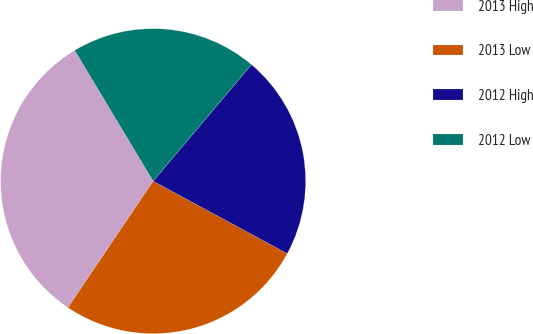Convert chart to OTSL. <chart><loc_0><loc_0><loc_500><loc_500><pie_chart><fcel>2013 High<fcel>2013 Low<fcel>2012 High<fcel>2012 Low<nl><fcel>31.97%<fcel>26.55%<fcel>21.73%<fcel>19.75%<nl></chart> 